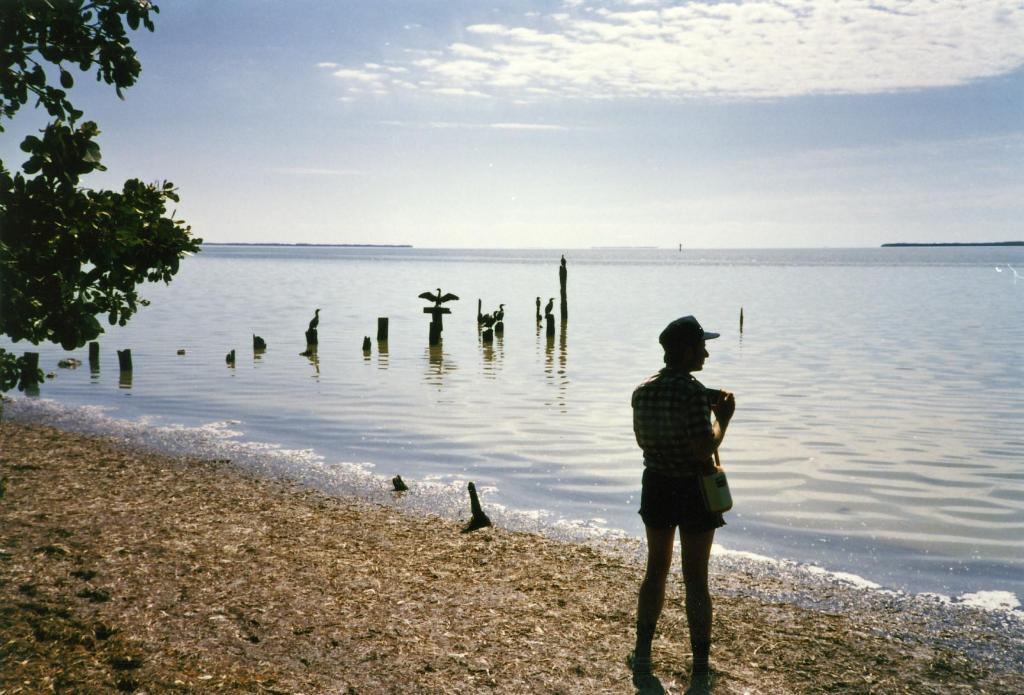Who is the main subject in the image? There is a man standing in the front of the image. What can be seen on the left side of the image? There are leaves on the left side of the image. What is visible in the background of the image? There is water and birds visible in the background of the image. How would you describe the weather in the image? The sky is cloudy in the image. What type of house can be seen in the background of the image? There is no house visible in the background of the image. What is the rod used for in the image? There is no rod present in the image. 